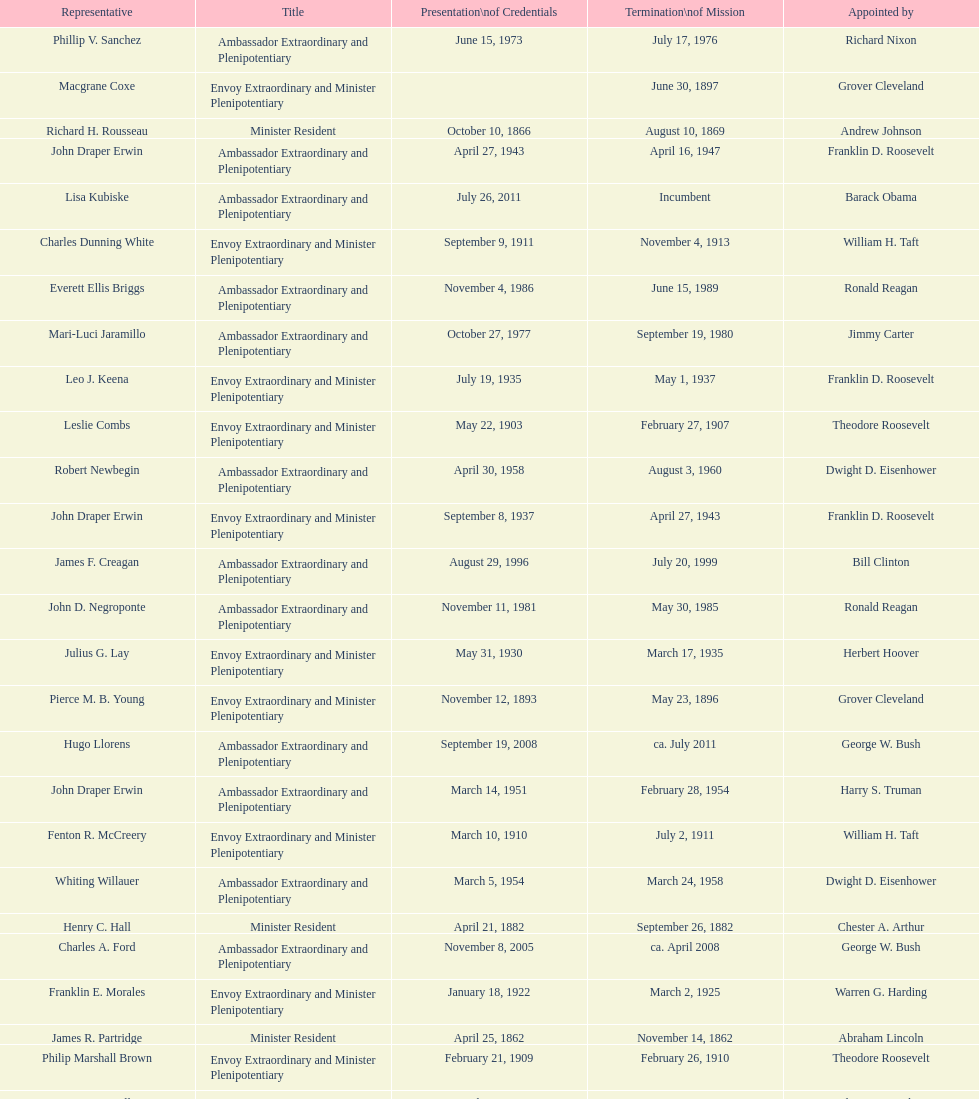Who was the last representative picked? Lisa Kubiske. 